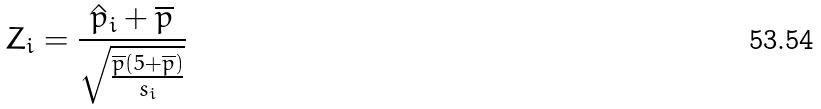Convert formula to latex. <formula><loc_0><loc_0><loc_500><loc_500>Z _ { i } = \frac { \hat { p } _ { i } + \overline { p } } { \sqrt { \frac { \overline { p } ( 5 + \overline { p } ) } { s _ { i } } } }</formula> 